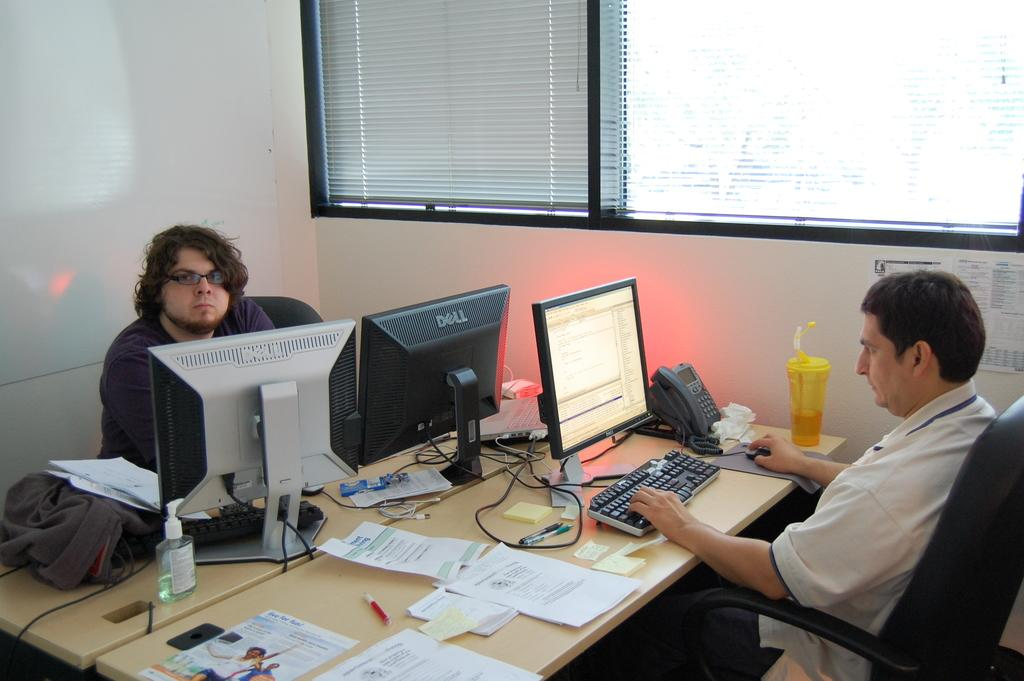<image>
Describe the image concisely. A man sits in front of two dell monitors. 